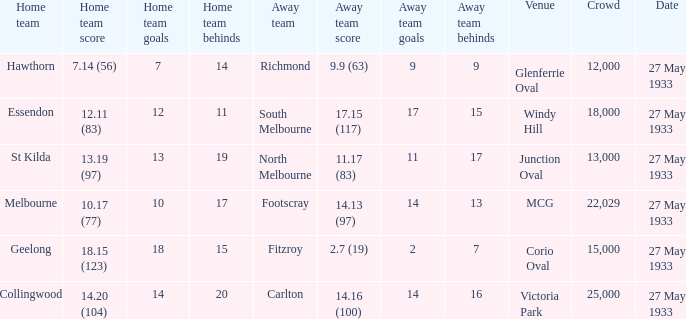In the match where the away team scored 2.7 (19), how many peopel were in the crowd? 15000.0. 